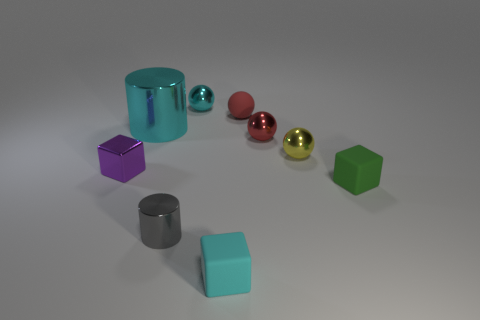What number of other objects are the same size as the green block?
Provide a succinct answer. 7. There is a matte block that is behind the tiny gray cylinder; what is its color?
Provide a short and direct response. Green. Do the small cyan object that is in front of the rubber ball and the green object have the same material?
Offer a very short reply. Yes. What number of shiny things are both in front of the cyan cylinder and to the right of the small gray object?
Your answer should be very brief. 2. What color is the cylinder behind the block on the left side of the sphere behind the red matte thing?
Provide a short and direct response. Cyan. How many other objects are the same shape as the small purple metal thing?
Keep it short and to the point. 2. There is a tiny metallic cube in front of the tiny yellow sphere; are there any small metal objects in front of it?
Make the answer very short. Yes. How many shiny objects are small yellow balls or big purple cubes?
Ensure brevity in your answer.  1. There is a cube that is both behind the tiny cyan matte object and left of the green thing; what material is it made of?
Provide a succinct answer. Metal. There is a small yellow thing on the left side of the matte cube right of the yellow metal ball; are there any cyan blocks to the left of it?
Provide a short and direct response. Yes. 